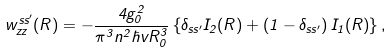<formula> <loc_0><loc_0><loc_500><loc_500>w _ { z z } ^ { s s ^ { \prime } } ( R ) = - \frac { 4 g _ { 0 } ^ { 2 } } { \pi ^ { 3 } n ^ { 2 } \hbar { v } R _ { 0 } ^ { 3 } } \left \{ \delta _ { s s ^ { \prime } } I _ { 2 } ( R ) + \left ( 1 - \delta _ { s s ^ { \prime } } \right ) I _ { 1 } ( R ) \right \} ,</formula> 